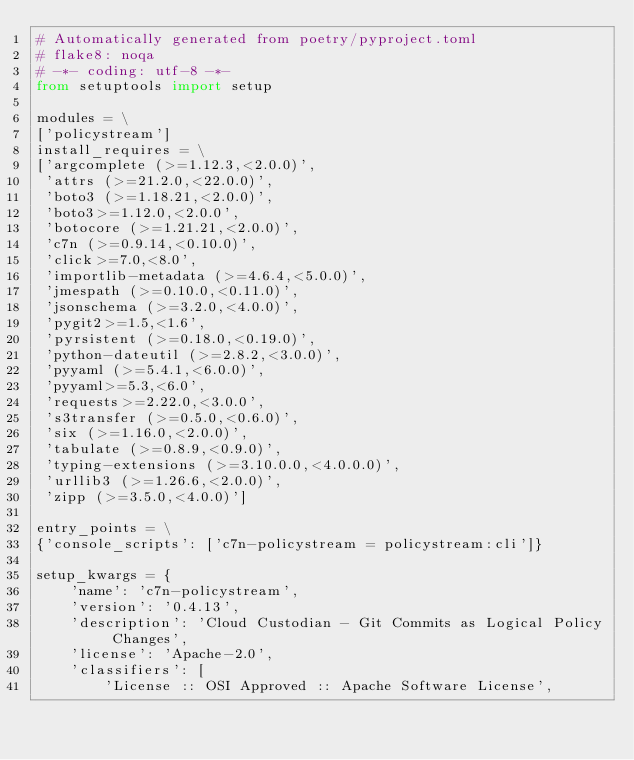Convert code to text. <code><loc_0><loc_0><loc_500><loc_500><_Python_># Automatically generated from poetry/pyproject.toml
# flake8: noqa
# -*- coding: utf-8 -*-
from setuptools import setup

modules = \
['policystream']
install_requires = \
['argcomplete (>=1.12.3,<2.0.0)',
 'attrs (>=21.2.0,<22.0.0)',
 'boto3 (>=1.18.21,<2.0.0)',
 'boto3>=1.12.0,<2.0.0',
 'botocore (>=1.21.21,<2.0.0)',
 'c7n (>=0.9.14,<0.10.0)',
 'click>=7.0,<8.0',
 'importlib-metadata (>=4.6.4,<5.0.0)',
 'jmespath (>=0.10.0,<0.11.0)',
 'jsonschema (>=3.2.0,<4.0.0)',
 'pygit2>=1.5,<1.6',
 'pyrsistent (>=0.18.0,<0.19.0)',
 'python-dateutil (>=2.8.2,<3.0.0)',
 'pyyaml (>=5.4.1,<6.0.0)',
 'pyyaml>=5.3,<6.0',
 'requests>=2.22.0,<3.0.0',
 's3transfer (>=0.5.0,<0.6.0)',
 'six (>=1.16.0,<2.0.0)',
 'tabulate (>=0.8.9,<0.9.0)',
 'typing-extensions (>=3.10.0.0,<4.0.0.0)',
 'urllib3 (>=1.26.6,<2.0.0)',
 'zipp (>=3.5.0,<4.0.0)']

entry_points = \
{'console_scripts': ['c7n-policystream = policystream:cli']}

setup_kwargs = {
    'name': 'c7n-policystream',
    'version': '0.4.13',
    'description': 'Cloud Custodian - Git Commits as Logical Policy Changes',
    'license': 'Apache-2.0',
    'classifiers': [
        'License :: OSI Approved :: Apache Software License',</code> 